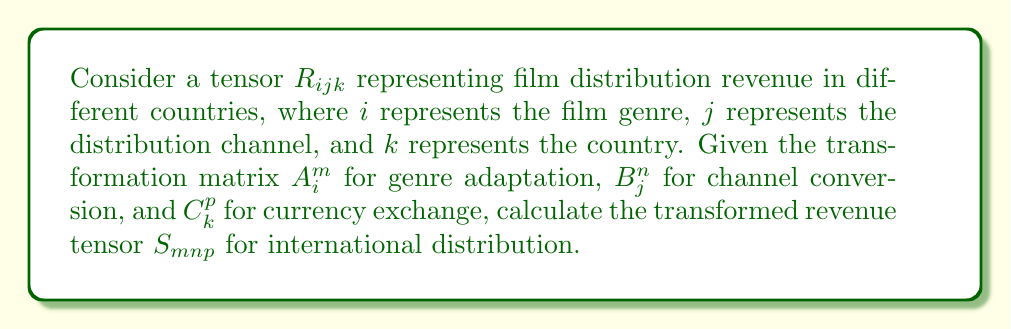Show me your answer to this math problem. To calculate the transformed revenue tensor, we need to apply the transformation matrices to our original tensor $R_{ijk}$. This is done using the tensor transformation rule:

1) The general form of the tensor transformation is:

   $$S_{mnp} = A^m_i B^n_j C^p_k R_{ijk}$$

2) This transformation involves three summations, one for each index:

   $$S_{mnp} = \sum_i \sum_j \sum_k A^m_i B^n_j C^p_k R_{ijk}$$

3) The summation is performed over all values of $i$, $j$, and $k$ in the original tensor.

4) Each element of the new tensor $S_{mnp}$ is calculated by multiplying the corresponding elements of the transformation matrices and the original tensor, then summing over all combinations.

5) The resulting tensor $S_{mnp}$ represents the transformed revenue, where:
   - $m$ represents the adapted genre
   - $n$ represents the converted distribution channel
   - $p$ represents the country with exchanged currency

This transformation allows for the revenue data to be adapted to different genre classifications, distribution channel categorizations, and currency conversions, which is crucial for international film distribution analysis.
Answer: $$S_{mnp} = A^m_i B^n_j C^p_k R_{ijk}$$ 